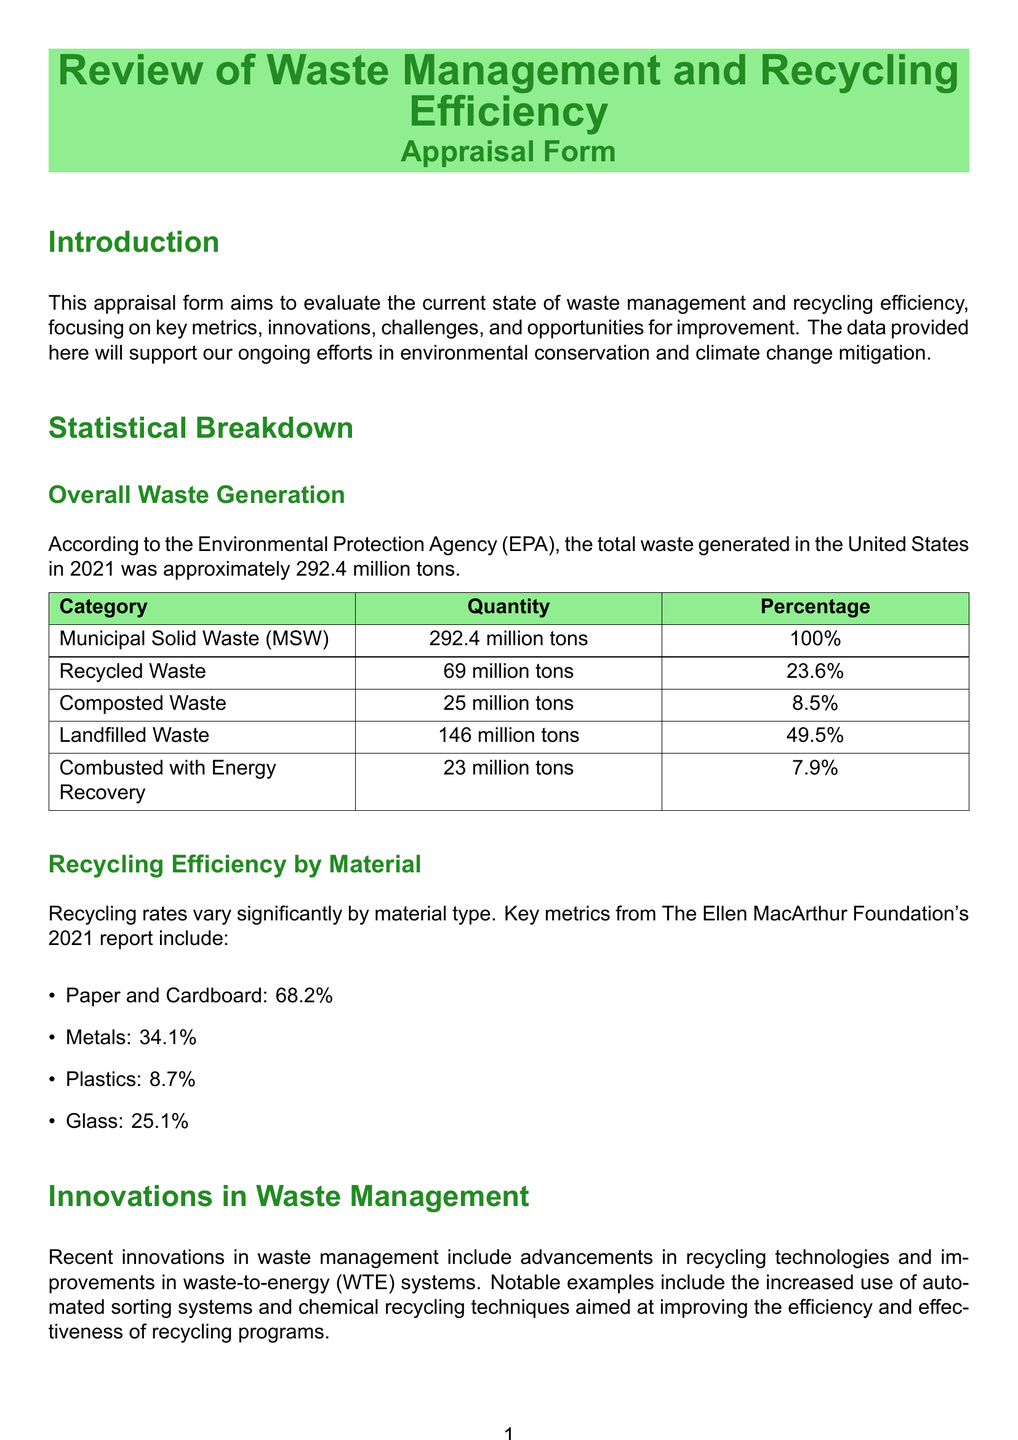what was the total waste generated in 2021? The total waste generated in the United States as reported in the document is 292.4 million tons.
Answer: 292.4 million tons how much waste was recycled? The amount of recycled waste reported is 69 million tons.
Answer: 69 million tons what percentage of waste was composted? The document states that 8.5% of the waste was composted.
Answer: 8.5% which category of recycling has the highest efficiency? Based on the provided metrics, Paper and Cardboard has the highest recycling efficiency at 68.2%.
Answer: Paper and Cardboard what is one major challenge in waste management? The document mentions contamination of recyclable materials as a significant challenge.
Answer: contamination of recyclable materials what innovation is noted in the document related to waste management? The use of automated sorting systems is highlighted as a recent innovation.
Answer: automated sorting systems what opportunity is suggested for improving public participation in recycling? Enhancing public education on proper recycling practices is suggested as an opportunity.
Answer: enhancing public education how much landfilled waste was reported? The amount of landfilled waste reported is 146 million tons.
Answer: 146 million tons what is the recycling rate for plastics? The document states that the recycling rate for plastics is 8.7%.
Answer: 8.7% 